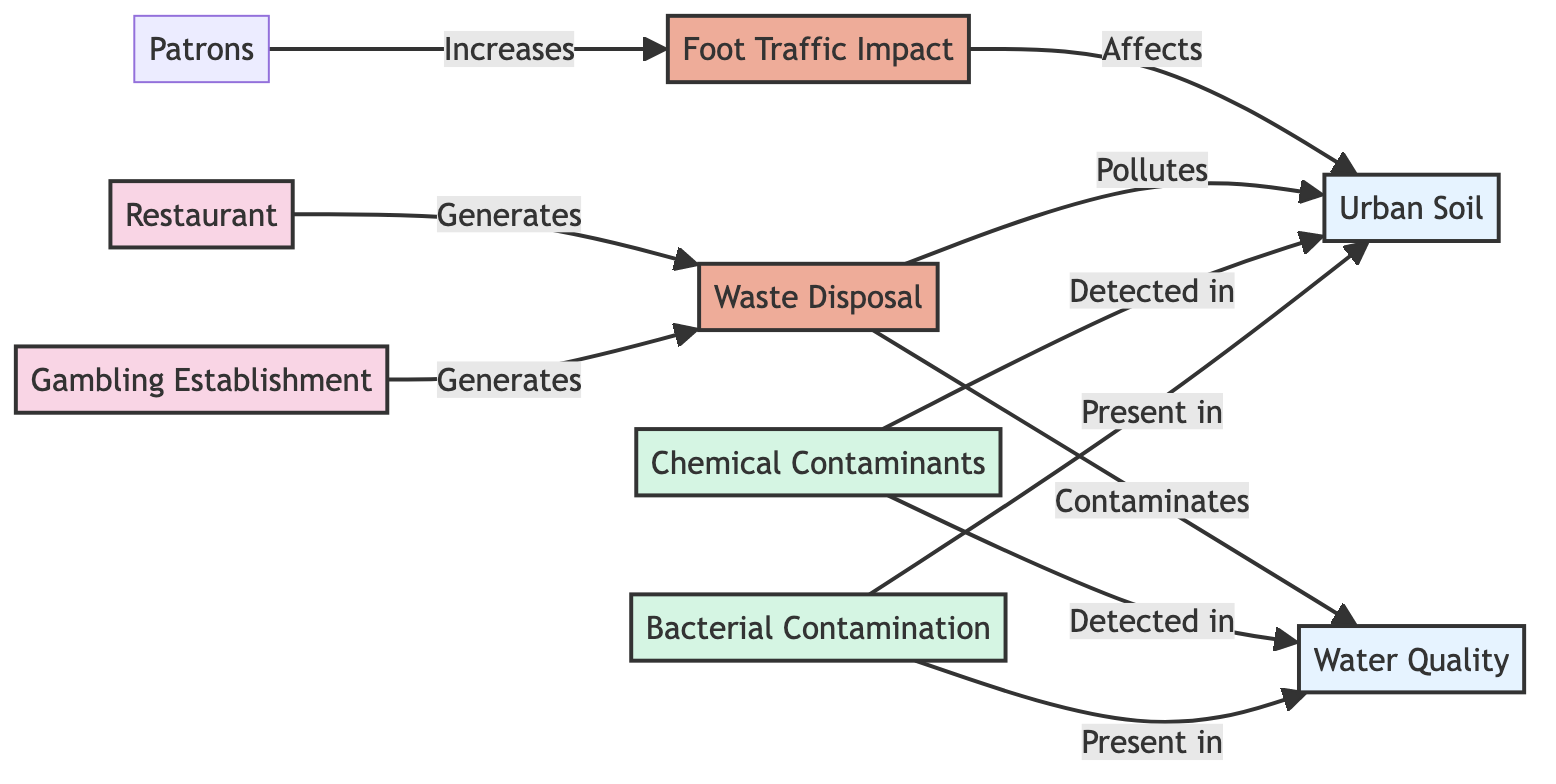What types of establishments are present in the diagram? The diagram includes two types of establishments depicted as "Restaurant" and "Gambling Establishment." Both are labeled under the same category, showing the sources of specific impacts on the environment.
Answer: Restaurant, Gambling Establishment How many chemical contaminants are connected to urban soil? The diagram indicates that there is one type of chemical contaminant detected in urban soil, represented as "Chemical Contaminants." By analyzing the connections from the corresponding node, we can see it influences urban soil directly, thus confirming its presence.
Answer: 1 What impact does foot traffic have on urban soil? According to the diagram, foot traffic increases the impact on urban soil. The arrows point from "Foot Traffic Impact" to "Urban Soil," supporting this relationship, indicative of the negative effects related to high patron foot traffic in urban areas.
Answer: Increases Which establishment generates waste disposal? The diagram shows that both the "Restaurant" and "Gambling Establishment" nodes lead to the "Waste Disposal" node. This indicates that waste is generated by both types of establishments contributing to the environment.
Answer: Restaurant, Gambling Establishment What is indicated about bacterial contamination in the water quality? The diagram shows that "Bacterial Contamination" is directly present in "Water Quality," indicating a direct connection and concern about bacterial content from environmental impacts linked to the establishments.
Answer: Present How does waste disposal affect water quality, according to the diagram? The diagram shows a directional relationship where "Waste Disposal" contaminates "Water Quality." Following the flow from waste disposal to water quality highlights the pollution effect represented in this relationship.
Answer: Pollutes Which two environmental factors are affected by the establishments? The establishments have an influence on both the "Urban Soil" and "Water Quality." By tracing connections from both establishments, we see they lead to impacts on these two environmental factors specifically.
Answer: Urban Soil, Water Quality What type of contamination is detected in both urban soil and water quality? The diagram indicates that "Chemical Contaminants" are detected in both "Urban Soil" and "Water Quality." This can be seen by the lines connecting the contaminant node to both environmental factors, confirming their widespread impact.
Answer: Chemical Contaminants How does the number of edges relate to the total impacts shown in the diagram? There are ten connectable edges in this diagram, detailing the interactions between nodes. Counting the connections gives insights into the complexity of interactions between establishments, waste, and environmental quality.
Answer: 10 